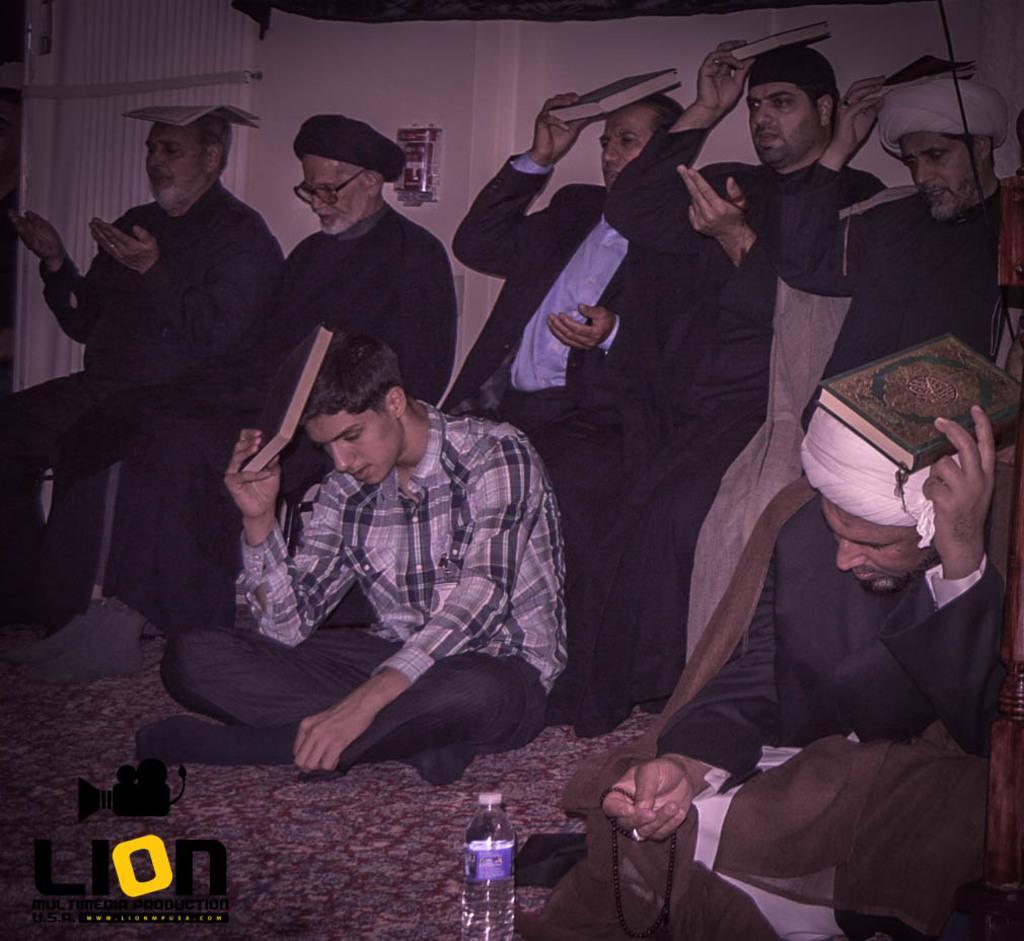In one or two sentences, can you explain what this image depicts? These people are sitting and holding books near their heads. On the floor there is a bottle. Bottom of the image there is a logo of camera.  